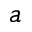Convert formula to latex. <formula><loc_0><loc_0><loc_500><loc_500>a</formula> 